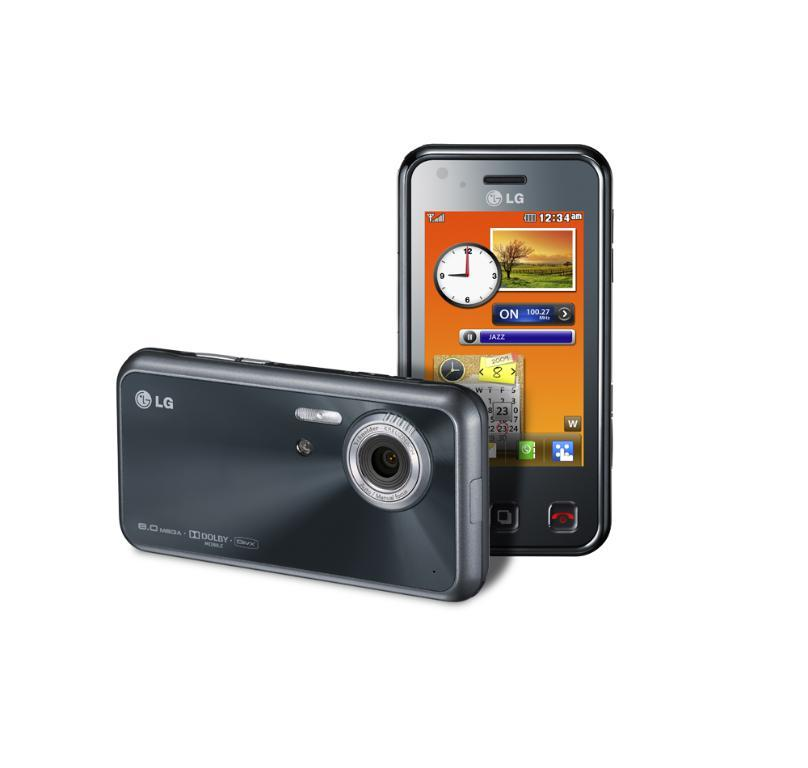Provide a one-sentence caption for the provided image. An LG phone is displayed on a white background. 